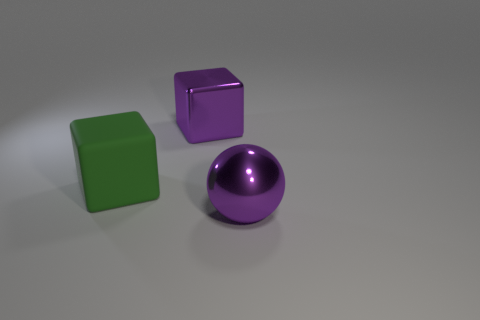Is there anything else that is the same material as the large green thing?
Make the answer very short. No. What shape is the big purple thing that is made of the same material as the sphere?
Ensure brevity in your answer.  Cube. Are there fewer large matte blocks that are to the right of the green block than tiny red matte cylinders?
Keep it short and to the point. No. How many metal objects are either green blocks or big red balls?
Keep it short and to the point. 0. Are there any metal cubes that have the same size as the ball?
Offer a very short reply. Yes. What shape is the big metallic thing that is the same color as the metallic block?
Provide a short and direct response. Sphere. How many metallic cubes are the same size as the purple ball?
Your answer should be very brief. 1. How many objects are big green cubes or large balls right of the green rubber object?
Provide a succinct answer. 2. What is the color of the metal cube?
Your answer should be very brief. Purple. The green block behind the large thing that is right of the purple thing behind the purple shiny sphere is made of what material?
Keep it short and to the point. Rubber. 